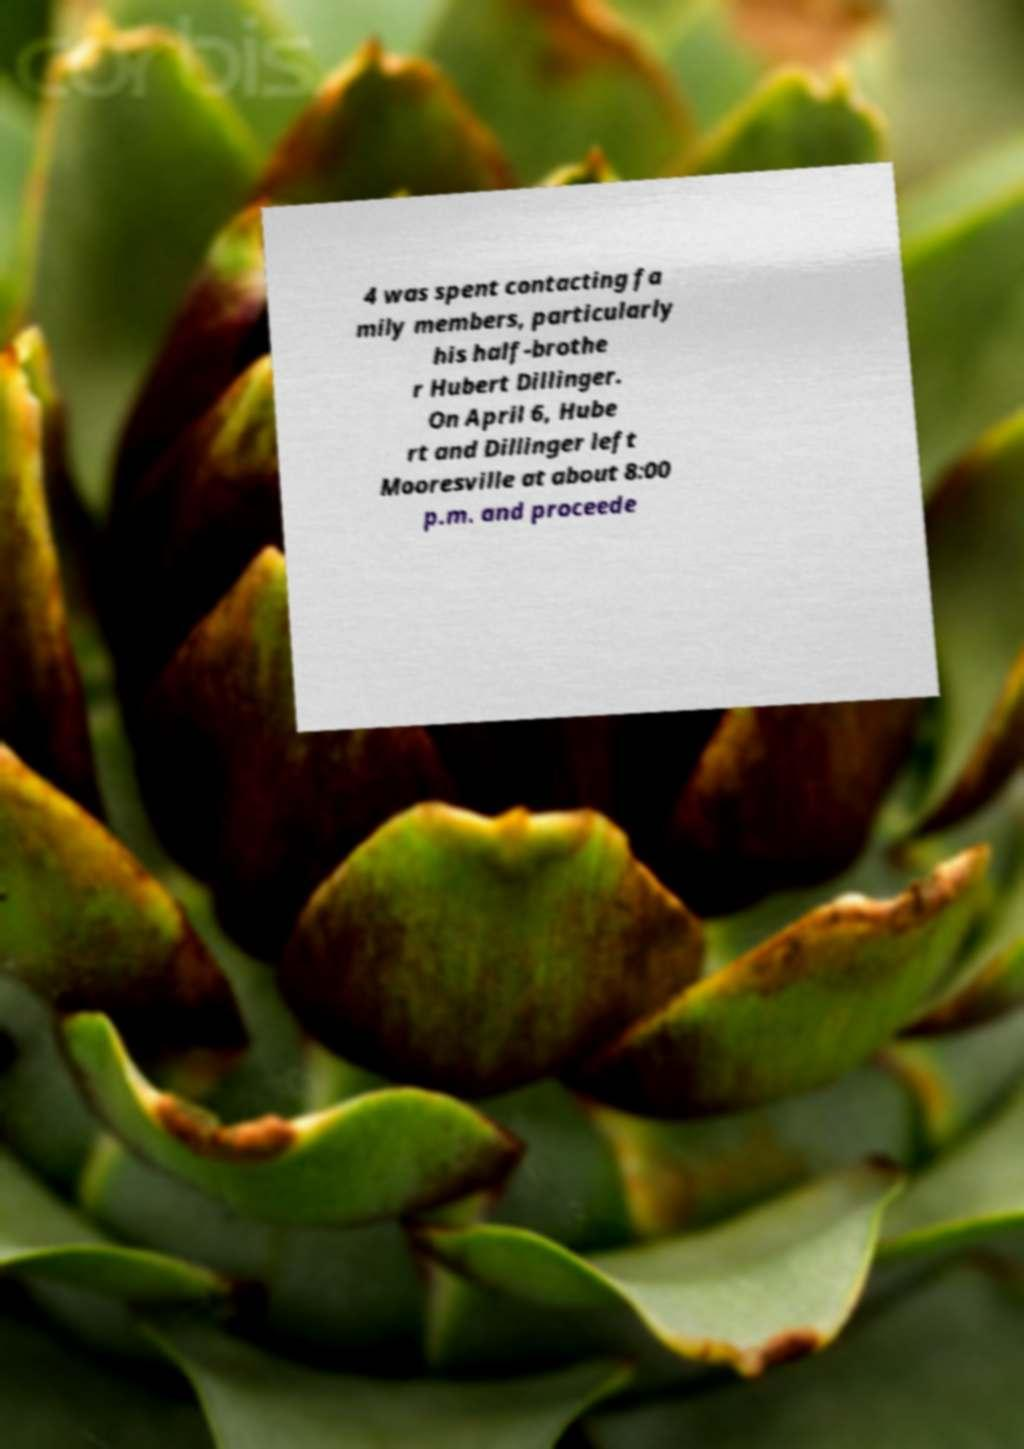Please read and relay the text visible in this image. What does it say? 4 was spent contacting fa mily members, particularly his half-brothe r Hubert Dillinger. On April 6, Hube rt and Dillinger left Mooresville at about 8:00 p.m. and proceede 